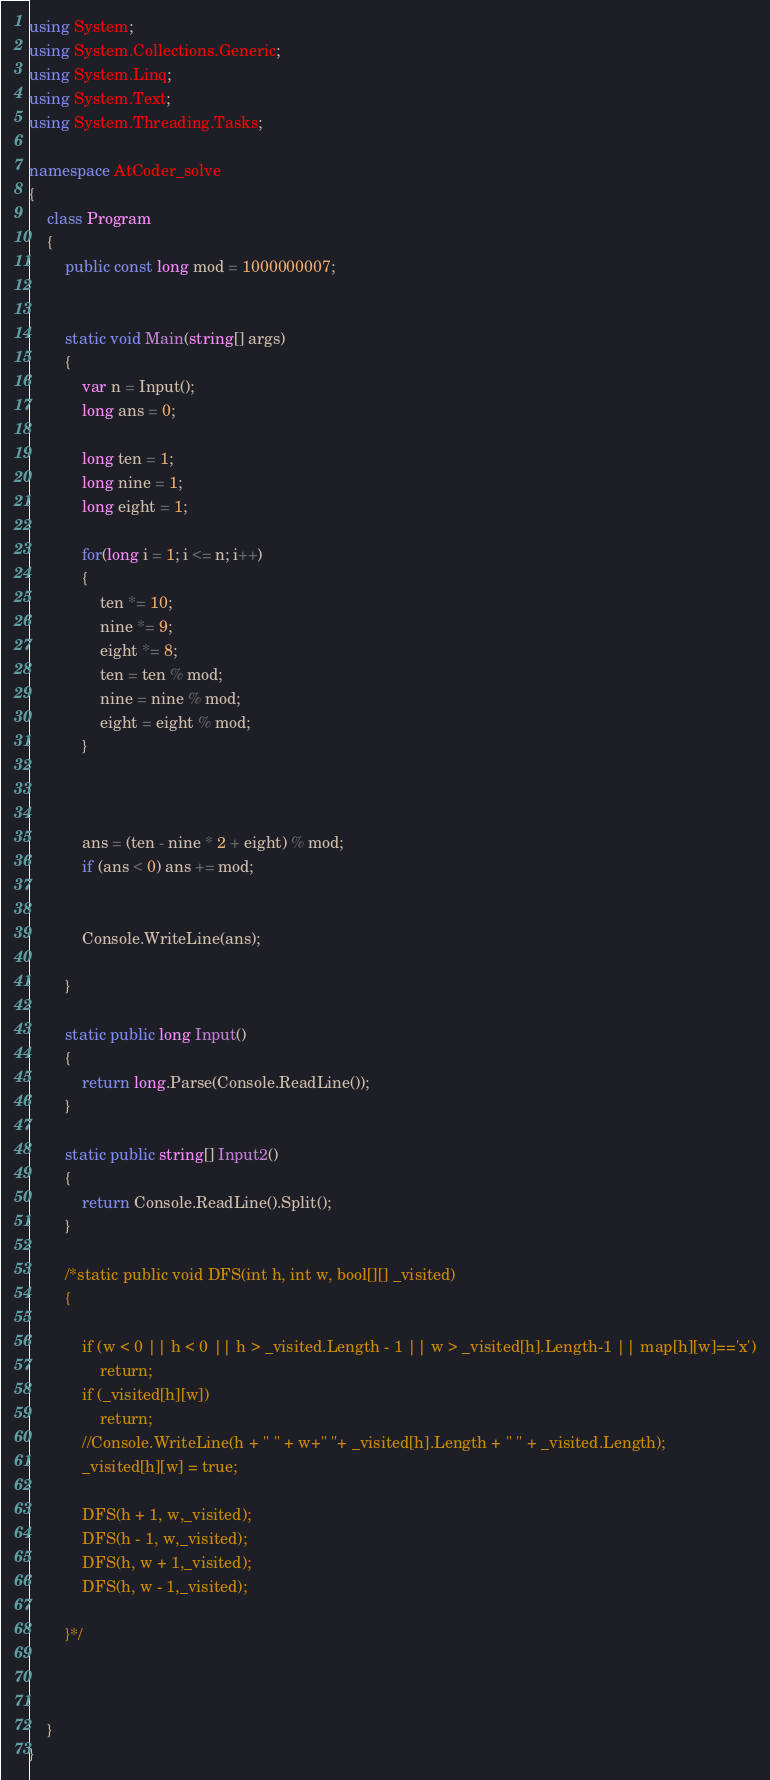<code> <loc_0><loc_0><loc_500><loc_500><_C#_>using System;
using System.Collections.Generic;
using System.Linq;
using System.Text;
using System.Threading.Tasks;

namespace AtCoder_solve
{
    class Program
    {
        public const long mod = 1000000007;
        

        static void Main(string[] args)
        {
            var n = Input();
            long ans = 0;

            long ten = 1;
            long nine = 1;
            long eight = 1;

            for(long i = 1; i <= n; i++)
            {
                ten *= 10;
                nine *= 9;
                eight *= 8;
                ten = ten % mod;
                nine = nine % mod;
                eight = eight % mod;
            }



            ans = (ten - nine * 2 + eight) % mod;
            if (ans < 0) ans += mod;


            Console.WriteLine(ans);

        }

        static public long Input()
        {
            return long.Parse(Console.ReadLine());
        }

        static public string[] Input2()
        {
            return Console.ReadLine().Split();
        }

        /*static public void DFS(int h, int w, bool[][] _visited)
        {
            
            if (w < 0 || h < 0 || h > _visited.Length - 1 || w > _visited[h].Length-1 || map[h][w]=='x')
                return;
            if (_visited[h][w])
                return;
            //Console.WriteLine(h + " " + w+" "+ _visited[h].Length + " " + _visited.Length);
            _visited[h][w] = true;

            DFS(h + 1, w,_visited);
            DFS(h - 1, w,_visited);
            DFS(h, w + 1,_visited);
            DFS(h, w - 1,_visited);

        }*/
        
        
        
    }
}
</code> 